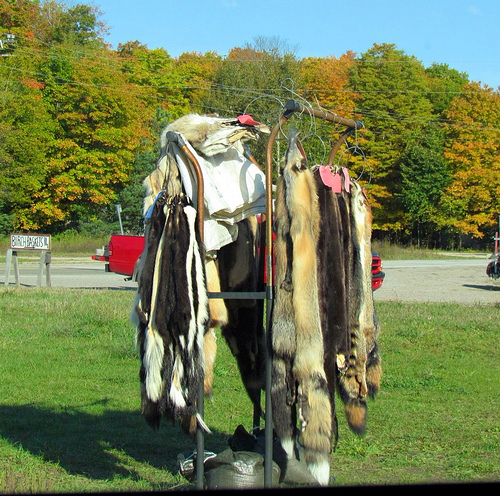<image>
Is the fur in the grass? No. The fur is not contained within the grass. These objects have a different spatial relationship. 